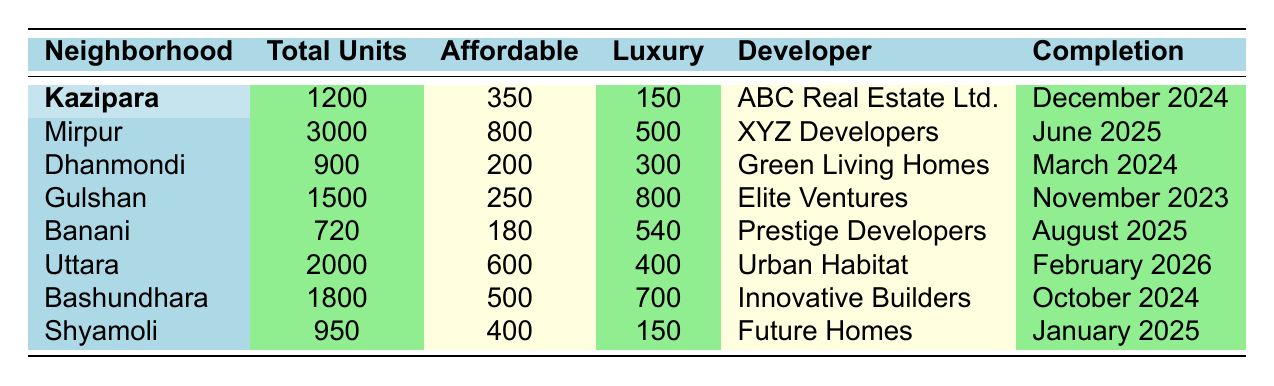What is the total number of residential units planned in Kazipara? From the table, the number of total units planned for Kazipara is explicitly listed as 1200.
Answer: 1200 How many affordable units are planned in the Mirpur neighborhood? The table states that Mirpur has 800 affordable units planned.
Answer: 800 Which developer is responsible for the residential development in Dhanmondi? According to the table, the developer for Dhanmondi is Green Living Homes.
Answer: Green Living Homes What is the difference between luxury and affordable units planned in Gulshan? In Gulshan, there are 800 luxury units and 250 affordable units. The difference is 800 - 250 = 550.
Answer: 550 How many total units are planned in Dhaka across all neighborhoods listed in the table? Adding the total units across all neighborhoods: 1200 (Kazipara) + 3000 (Mirpur) + 900 (Dhanmondi) + 1500 (Gulshan) + 720 (Banani) + 2000 (Uttara) + 1800 (Bashundhara) + 950 (Shyamoli) = 12170.
Answer: 12170 Which neighborhood has the most affordable units planned? By comparing affordable units, Mirpur has the highest with 800 units, more than any other listed neighborhood.
Answer: Mirpur Will the residential development in Gulshan be completed before the one in Kazipara? Gulshan is set to be completed in November 2023, while Kazipara will finish in December 2024, meaning Gulshan will be completed first.
Answer: Yes What is the average number of luxury units planned across all neighborhoods? The total luxury units are calculated as follows: 150 (Kazipara) + 500 (Mirpur) + 300 (Dhanmondi) + 800 (Gulshan) + 540 (Banani) + 400 (Uttara) + 700 (Bashundhara) + 150 (Shyamoli) = 3560. There are 8 neighborhoods, so the average is 3560/8 = 445.
Answer: 445 Is there a neighborhood where the number of luxury units planned is greater than the number of affordable units planned? Yes, in Gulshan, the number of luxury units (800) is greater than affordable units (250).
Answer: Yes How many units combined are planned in Bashundhara and Shyamoli? Adding units from Bashundhara (1800) and Shyamoli (950), we get 1800 + 950 = 2750.
Answer: 2750 